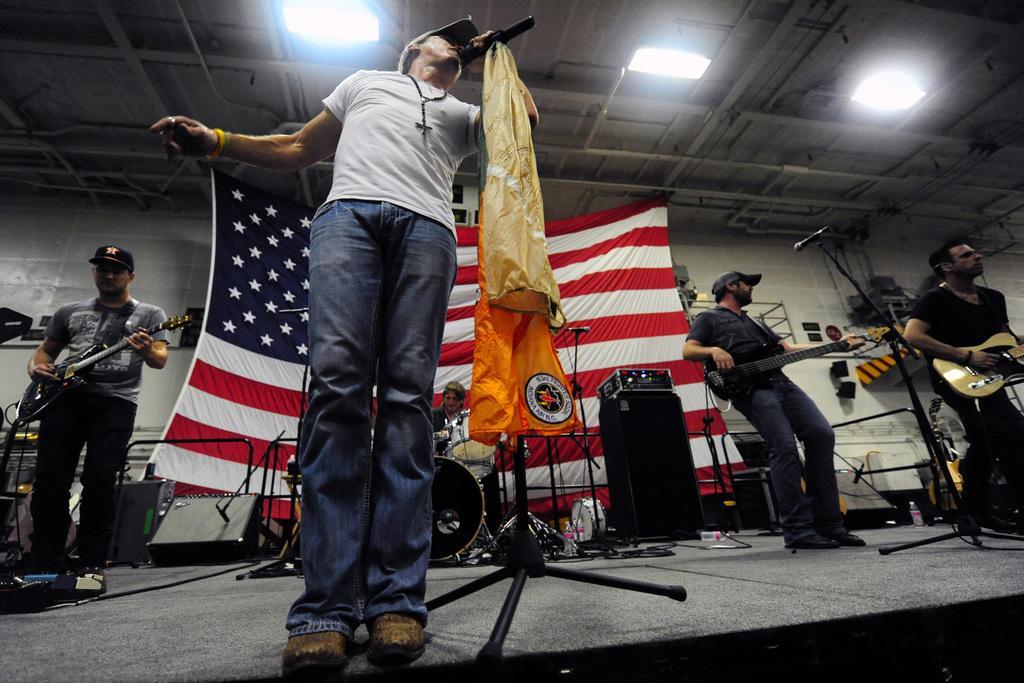Describe this image in one or two sentences. In this image we can see this person standing and holding a mic through which he is singing. In the background we can see this persons are holding a guitar in their hands and playing it. This person is playing electronic drums. This is the flag. 